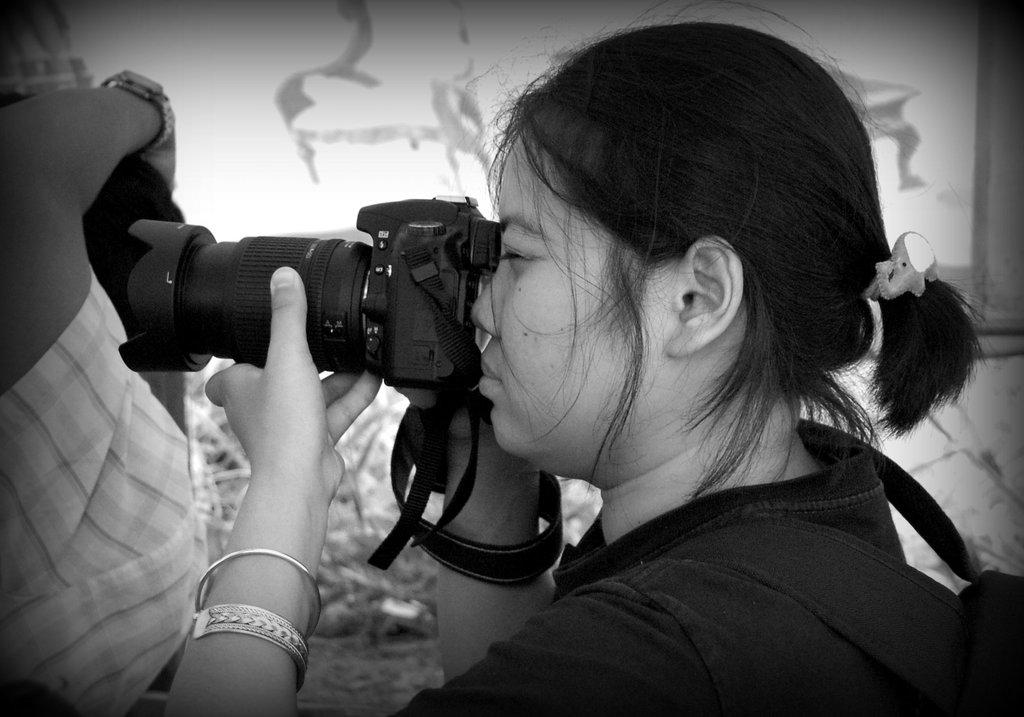What is the main subject of the image? There is a person in the image. What is the person wearing? The person is wearing a black shirt. What is the person carrying on her back? The person is carrying a bag on her back. What is the person holding in her hand? The person is holding a camera in her hand. What is the person doing with the camera? The person is clicking a picture. What type of stocking is the person wearing in the image? There is no mention of stockings in the image, so it cannot be determined what type the person might be wearing. 